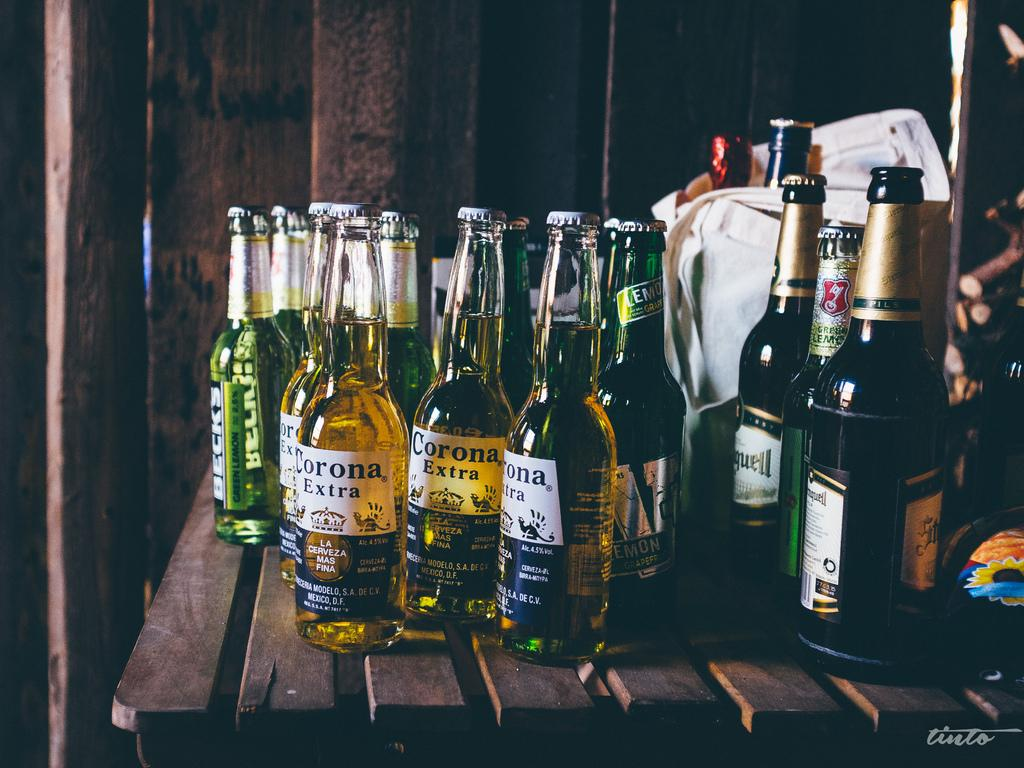<image>
Provide a brief description of the given image. Bottles of different kinds of bear, including Corona Extra, are on a table. 